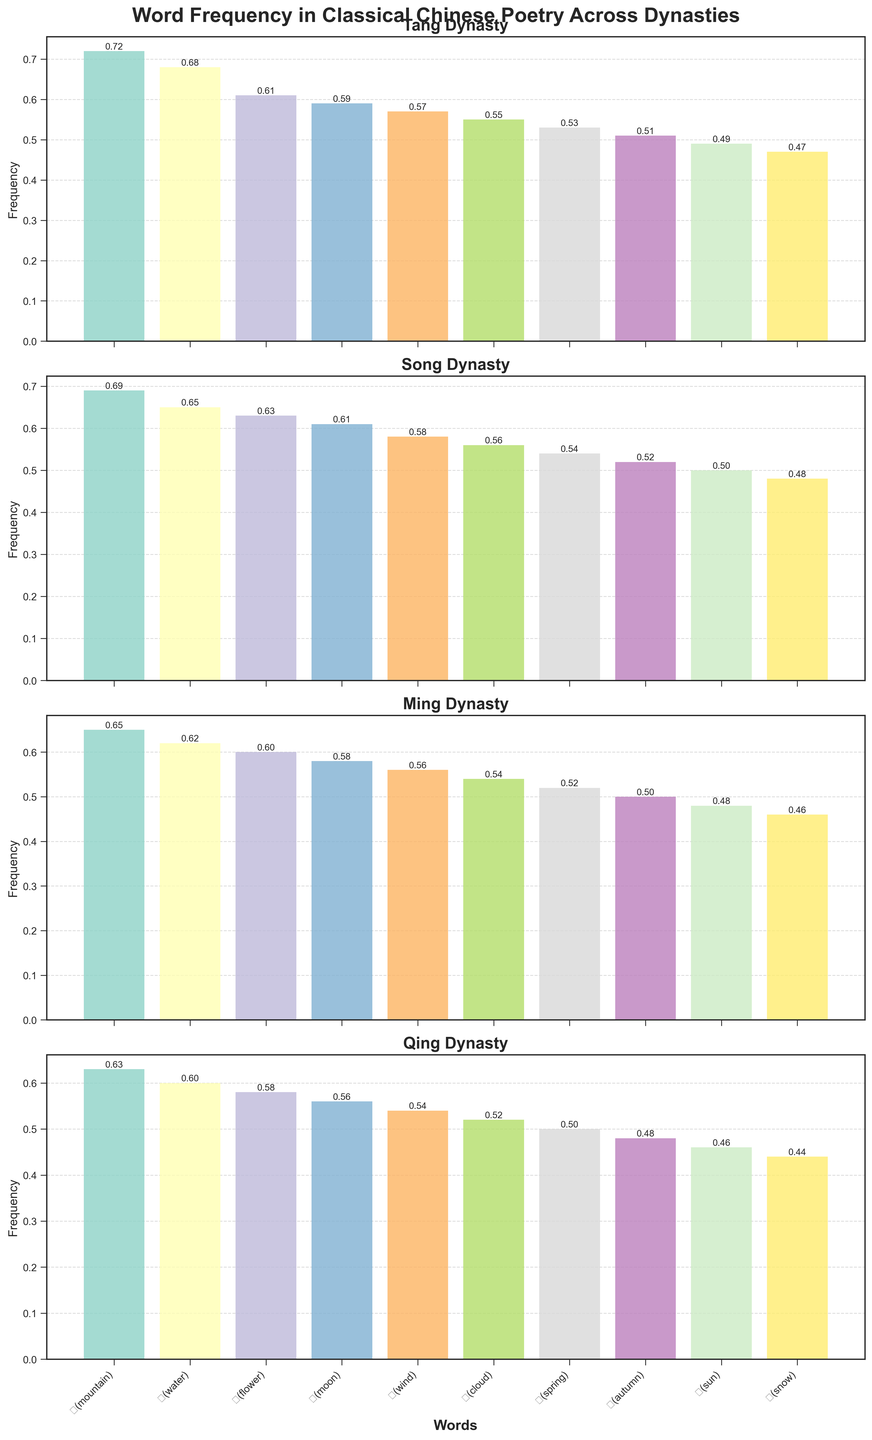Which dynasty has the highest frequency of the word "山(mountain)"? Look at the bar heights for "山(mountain)" across the different subplots. The Tang dynasty has the highest bar for "山(mountain)" with a frequency of 0.72.
Answer: Tang Which word has the lowest frequency during the Qing dynasty? Examine the bar heights within the Qing dynasty subplot. The word "雪(snow)" has the smallest bar with a frequency of 0.44.
Answer: 雪(snow) How does the frequency of "月(moon)" change from the Tang dynasty to the Qing dynasty? Compare the bars for "月(moon)" across all four subplots. The frequency is 0.59 in Tang, 0.61 in Song, 0.58 in Ming, and 0.56 in Qing. The frequency decreases from Tang to Qing.
Answer: It decreases Which two words have the smallest difference in frequency during the Ming dynasty? Look at the bar heights within the Ming dynasty subplot and find the two closest in height. The words "秋(autumn)" with 0.50 and "春(spring)" with 0.52 have the smallest difference of 0.02.
Answer: 秋(autumn) and 春(spring) Is there a word that maintains a similar frequency (within 0.02) across all four dynasties? Check the frequencies for each word across the four subplots. The word "风(wind)" has frequencies of 0.57 (Tang), 0.58 (Song), 0.56 (Ming), and 0.54 (Qing), all within a 0.04 range. While it's close, no word maintains a frequency within 0.02 across all four dynasties.
Answer: No, but 风(wind) is close What is the total frequency of "水(water)" across all dynasties? Sum the frequencies of "水(water)" from each dynasty subplot: 0.68 (Tang) + 0.65 (Song) + 0.62 (Ming) + 0.60 (Qing) = 2.55.
Answer: 2.55 Which dynasty has the smallest average word frequency for the words shown? Calculate the average frequency for each dynasty:
Tang: (0.72+0.68+0.61+0.59+0.57+0.55+0.53+0.51+0.49+0.47)/10 = 5.72/10 = 0.572
Song: (0.69+0.65+0.63+0.61+0.58+0.56+0.54+0.52+0.50+0.48)/10 = 5.76/10 = 0.576
Ming: (0.65+0.62+0.60+0.58+0.56+0.54+0.52+0.50+0.48+0.46)/10 = 5.51/10 = 0.551
Qing: (0.63+0.60+0.58+0.56+0.54+0.52+0.50+0.48+0.46+0.44)/10 = 5.31/10 = 0.531 Therefore, the Qing dynasty has the smallest average word frequency.
Answer: Qing Which word shows the largest drop in frequency from the Tang to the Qing dynasty? Calculate the difference in frequencies for each word between the Tang and Qing dynasties: "山(mountain)": 0.72 - 0.63 = 0.09, "水(water)": 0.68 - 0.60 = 0.08, "花(flower)": 0.61 - 0.58 = 0.03, "月(moon)": 0.59 - 0.56 = 0.03, "风(wind)": 0.57 - 0.54 = 0.03, "云(cloud)": 0.55 - 0.52 = 0.03, "春(spring)": 0.53 - 0.50 = 0.03, "秋(autumn)": 0.51 - 0.48 = 0.03, "日(sun)": 0.49 - 0.46 = 0.03, "雪(snow)": 0.47 - 0.44 = 0.03. "山(mountain)" has the largest drop in frequency of 0.09.
Answer: 山(mountain) 